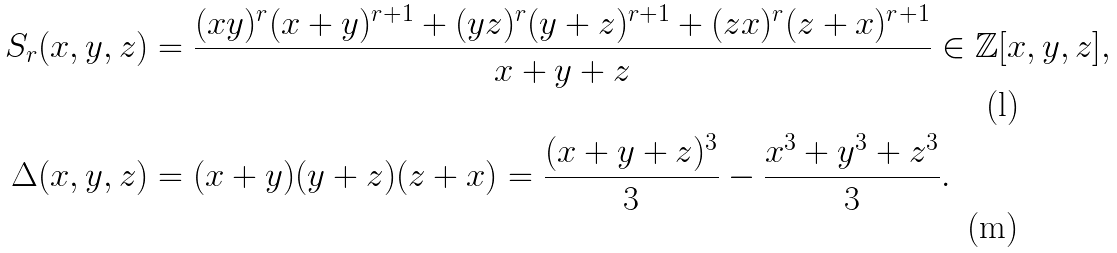Convert formula to latex. <formula><loc_0><loc_0><loc_500><loc_500>S _ { r } ( x , y , z ) & = \frac { ( x y ) ^ { r } ( x + y ) ^ { r + 1 } + ( y z ) ^ { r } ( y + z ) ^ { r + 1 } + ( z x ) ^ { r } ( z + x ) ^ { r + 1 } } { x + y + z } \in \mathbb { Z } [ x , y , z ] , \\ \Delta ( x , y , z ) & = ( x + y ) ( y + z ) ( z + x ) = \frac { ( x + y + z ) ^ { 3 } } { 3 } - \frac { x ^ { 3 } + y ^ { 3 } + z ^ { 3 } } { 3 } .</formula> 